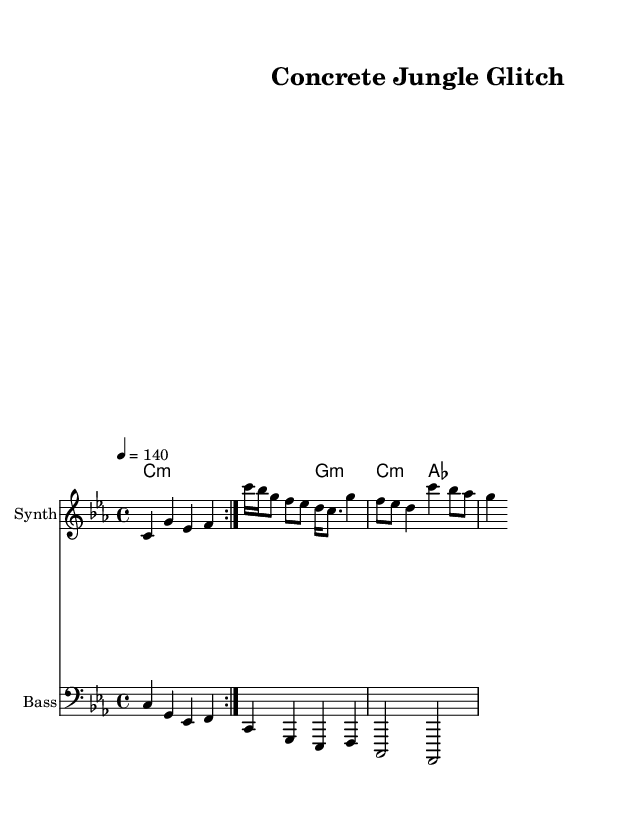What is the key signature of this music? The key signature shown is C minor, as indicated by the presence of three flats (B♭, E♭, A♭) on the staff.
Answer: C minor What is the time signature of this music? The time signature is shown as 4/4, which indicates four beats per measure, with a quarter note receiving one beat.
Answer: 4/4 What is the tempo marking of this piece? The tempo marking indicates a speed of 140 beats per minute, shown by the notation "4 = 140" at the beginning.
Answer: 140 How many times is the intro repeated? The intro section is marked to be repeated twice, as indicated by the "repeat volta 2" notation.
Answer: 2 Which instrument is primarily playing the melody? The instrument labeled at the top of the staff for the melody part is "Synth," indicating that this line is played by a synthesizer.
Answer: Synth What is the chord progression in the verse section? The verse section includes the chord progression C minor to G minor, which is reflected in the harmony part.
Answer: C minor, G minor What type of bassline is used throughout this piece? The bassline is a typical electronic bassline featuring a repeating rhythmic pattern that complements the melody and harmonies, which is characteristic of glitch-hop and breakbeat genres.
Answer: Electronic bassline 